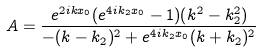Convert formula to latex. <formula><loc_0><loc_0><loc_500><loc_500>A = \frac { e ^ { 2 i k x _ { 0 } } ( e ^ { 4 i k _ { 2 } x _ { 0 } } - 1 ) ( k ^ { 2 } - k _ { 2 } ^ { 2 } ) } { - ( k - k _ { 2 } ) ^ { 2 } + e ^ { 4 i k _ { 2 } x _ { 0 } } ( k + k _ { 2 } ) ^ { 2 } }</formula> 